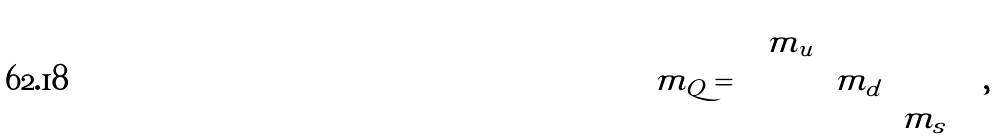<formula> <loc_0><loc_0><loc_500><loc_500>m _ { Q } = \begin{pmatrix} m _ { u } & & \\ & m _ { d } & \\ & & m _ { s } \end{pmatrix} \, ,</formula> 